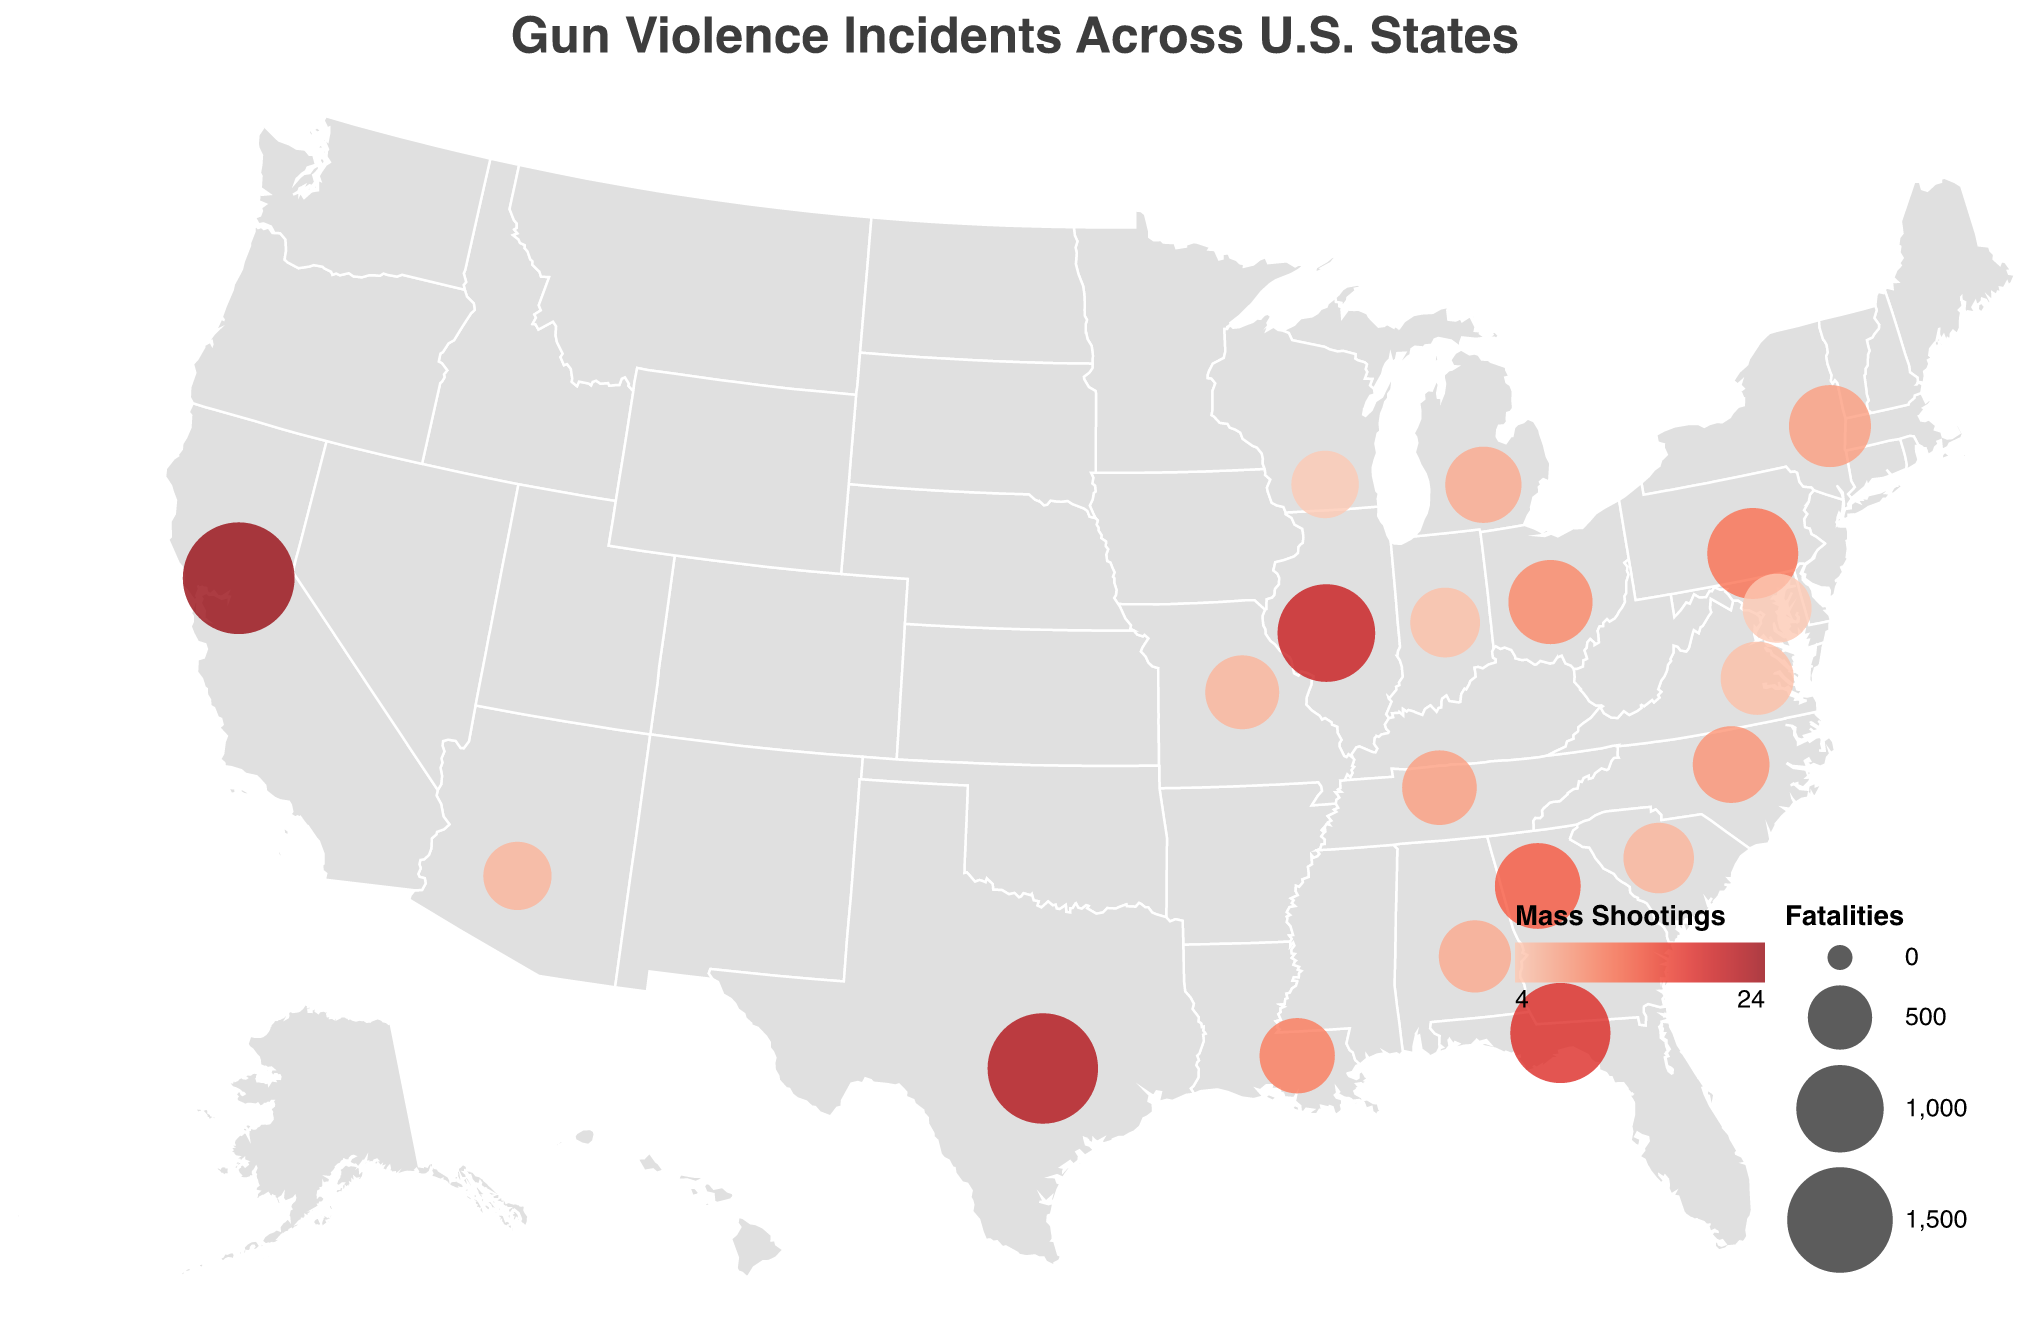What is the title of the figure? The title of a figure typically appears at the top. In this case, it is specified in the provided code under the "title" attribute.
Answer: Gun Violence Incidents Across U.S. States Which state has the highest number of fatalities? By observing the figure's legend and the relative sizes of the circles, the state with the largest circle for fatalities can be identified as having the highest fatalities.
Answer: California How many mass shootings are in Illinois? The tooltip data provides information about each state. By identifying Illinois in the figure and checking the tooltip, the number of mass shootings is revealed.
Answer: 20 Which state has fewer fatalities, Ohio or New York? Comparing the circles' sizes for Ohio and New York or using the tooltip, you can see that Ohio has fewer fatalities.
Answer: Ohio Calculate the total number of fatalities in Texas and Florida. Sum the fatalities for Texas and Florida (1650 in Texas and 1340 in Florida). The total is 1650 + 1340 = 2990.
Answer: 2990 Which state has the highest number of injuries, and how many are there? By looking at the circle sizes (indicating fatalities) and using the tooltips for details, California is identified with the highest fatalities; its tooltip indicates it also has 7105 injuries, which is the highest.
Answer: California, 7105 What is the median number of fatalities among all the listed states? List the total fatalities from all the states and find the middle value:
1690, 1650, 1340, 1270, 1090, 960, 920, 870, 750, 740, 720, 705, 690, 675, 655, 620, 605, 590, 575, 560
Arranging these in order and finding the median of the 20 values:
   Sorted: 560, 575, 590, 605, 620, 655, 675, 690, 705, 720, 740, 750, 870, 920, 960, 1090, 1270, 1340, 1650, 1690
Median is the average of 10th and 11th values: (720 + 740) / 2 = 730.
Answer: 730 Among the states with more than 10 mass shootings, which one has the fewest injuries? Refer to the tooltip information and compare states with more than 10 mass shootings. Pennsylvania, with 12 mass shootings, has the fewest injuries at 2730.
Answer: Pennsylvania Which state has the highest number of mass shootings? The color intensity of the circles represents mass shootings; the tooltip or the most intense color indicates the highest number. California has the highest with 24 mass shootings.
Answer: California 